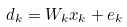Convert formula to latex. <formula><loc_0><loc_0><loc_500><loc_500>{ { d } _ { k } } = { { W } _ { k } } { { x } _ { k } } + { { e } _ { k } }</formula> 